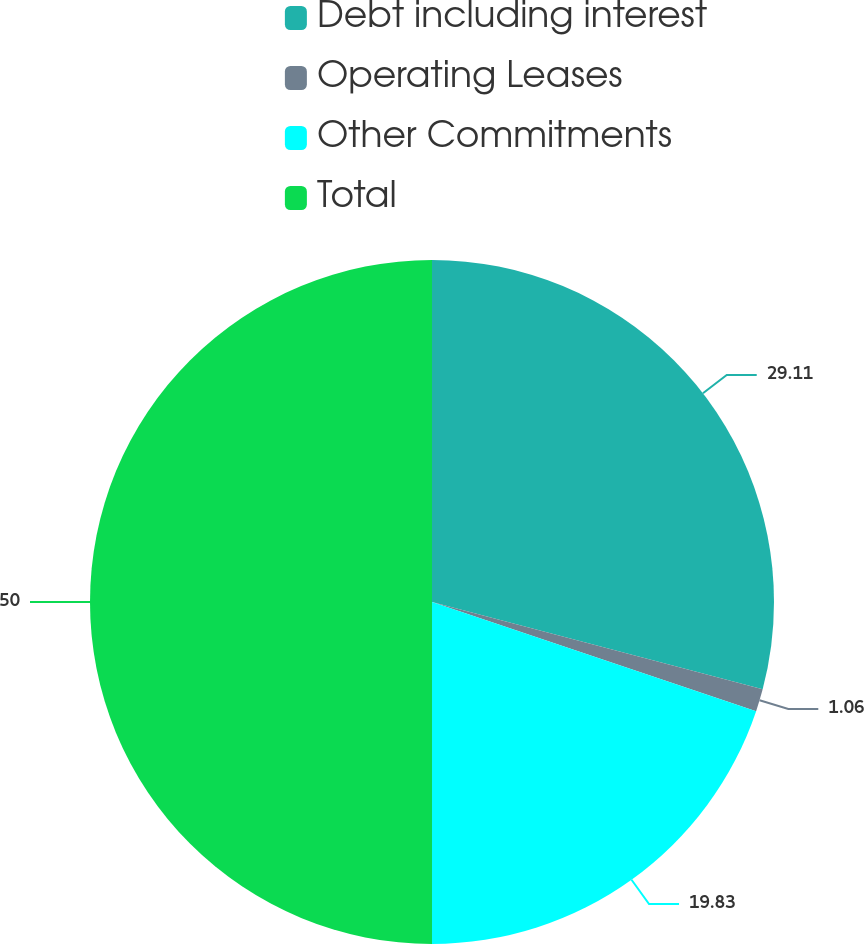Convert chart to OTSL. <chart><loc_0><loc_0><loc_500><loc_500><pie_chart><fcel>Debt including interest<fcel>Operating Leases<fcel>Other Commitments<fcel>Total<nl><fcel>29.11%<fcel>1.06%<fcel>19.83%<fcel>50.0%<nl></chart> 